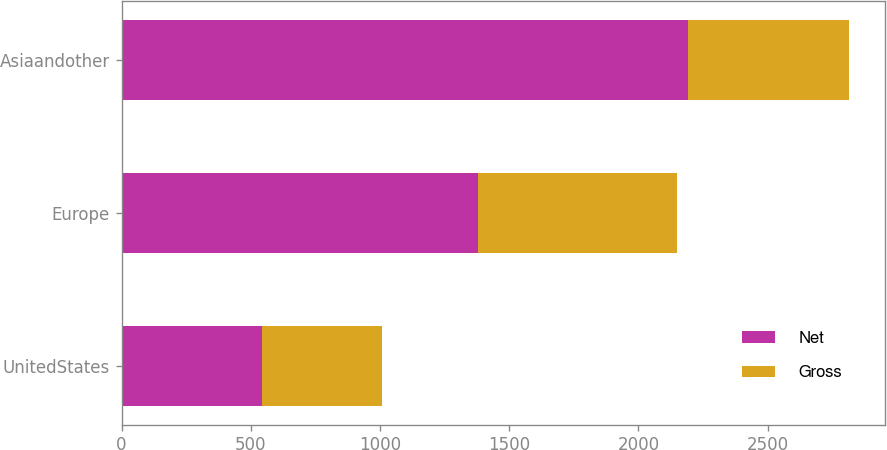<chart> <loc_0><loc_0><loc_500><loc_500><stacked_bar_chart><ecel><fcel>UnitedStates<fcel>Europe<fcel>Asiaandother<nl><fcel>Net<fcel>542<fcel>1379<fcel>2190<nl><fcel>Gross<fcel>466<fcel>771<fcel>625<nl></chart> 